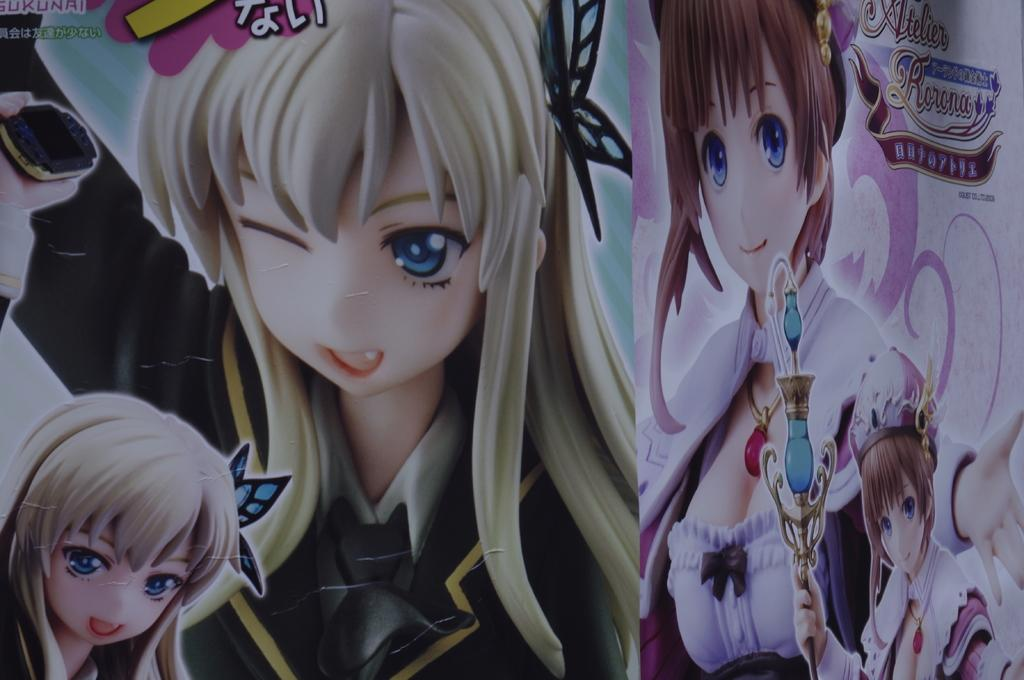What type of image is being described? The image is an animation. Where can text be found in the image? There is text in the top left corner and top right corner of the image. How many people are in the foreground of the image? There are four people in the foreground of the image. What type of wax can be seen melting on the road in the image? There is no wax or road present in the image; it is an animation with text and people in the foreground. How many leaves are visible on the ground in the image? There are no leaves visible in the image. 